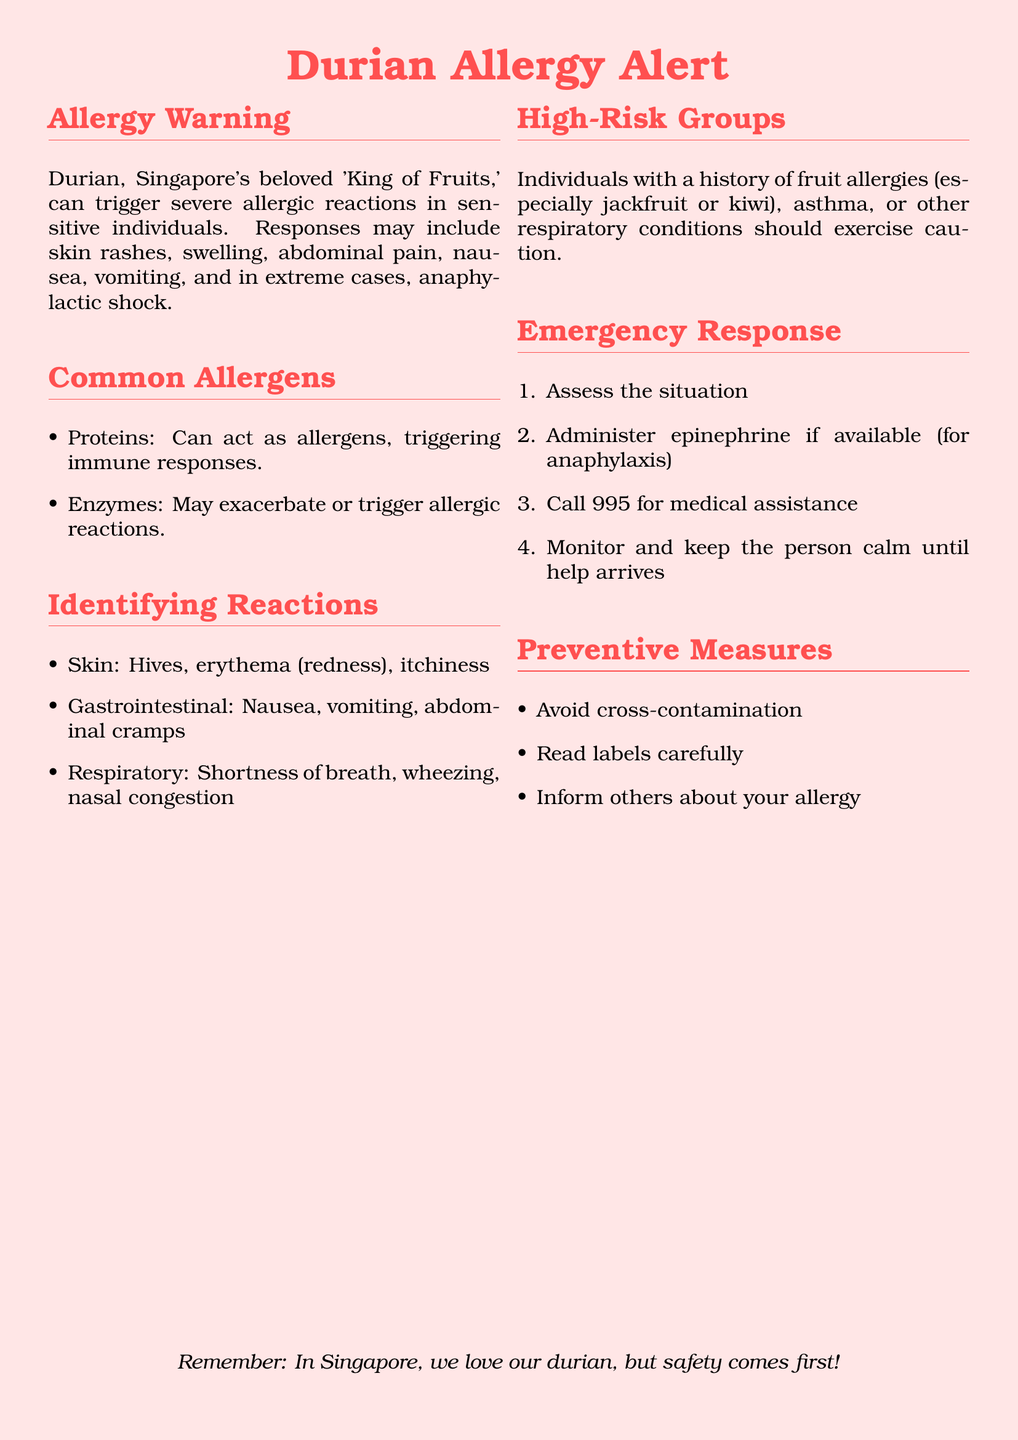What is the title of the warning label? The title of the warning label is prominently displayed at the top of the document.
Answer: Durian Allergy Alert What are the common allergens in durian? The document lists specific allergens related to durian consumption.
Answer: Proteins and Enzymes What emergency number should be called for medical assistance? The document specifies the emergency number for immediate help in case of an allergic reaction.
Answer: 995 What is one symptom of respiratory reactions? The document outlines symptoms associated with respiratory reactions to durian.
Answer: Shortness of breath Who should exercise caution when consuming durian? The document specifies particular groups of individuals at higher risk for allergic reactions.
Answer: Individuals with a history of fruit allergies What should you do if anaphylaxis occurs? The emergency response section details specific actions to take in the event of an anaphylactic reaction.
Answer: Administer epinephrine What is the suggested preventive measure regarding cross-contamination? The document provides preventive strategies for those with durian allergies, mentioning the handling of the fruit.
Answer: Avoid cross-contamination What type of fruits may indicate a risk for durian allergy? The document mentions certain fruits that could signal heightened allergic responses when it comes to durian.
Answer: Jackfruit or kiwi 